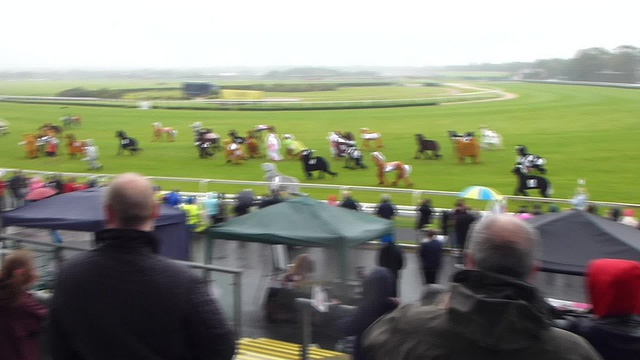Describe the objects in this image and their specific colors. I can see people in white, olive, gray, and black tones, people in white, black, and gray tones, people in white, black, gray, and darkgray tones, umbrella in white, gray, darkgray, and black tones, and umbrella in white and gray tones in this image. 